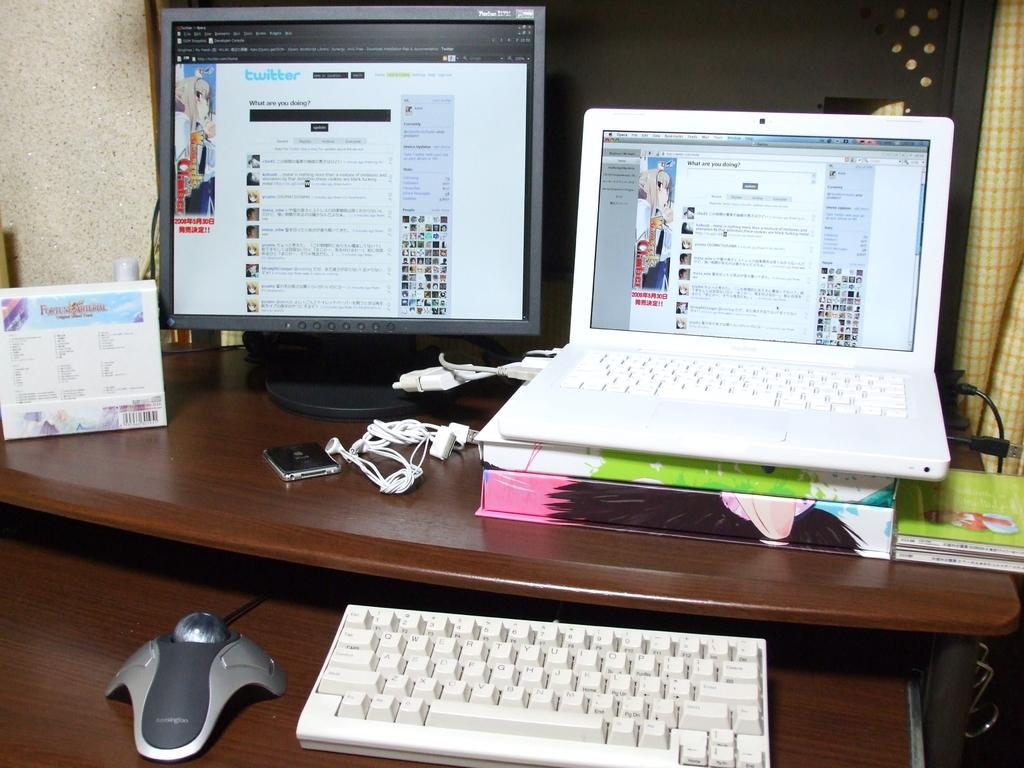What is the main object in the middle of the image? There is a table in the middle of the image. What electronic devices are on the table? A laptop, a monitor, a keyboard, a mouse, and headphones are on the table. Are there any non-electronic items on the table? Yes, there is a book on the table. What can be seen in the background of the image? There is a curtain and a wall in the background of the image. How many items can be seen on the table? There are at least nine items visible on the table, including the laptop, monitor, keyboard, mouse, headphones, book, and other items. What type of plants are growing on the table in the image? There are no plants visible on the table in the image. How many men are walking in the background of the image? There are no men present in the image, and therefore no one is walking in the background. 